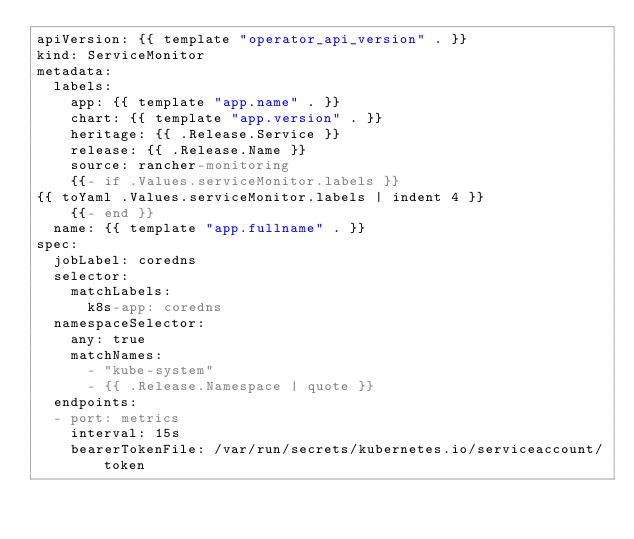<code> <loc_0><loc_0><loc_500><loc_500><_YAML_>apiVersion: {{ template "operator_api_version" . }}
kind: ServiceMonitor
metadata:
  labels:
    app: {{ template "app.name" . }}
    chart: {{ template "app.version" . }}
    heritage: {{ .Release.Service }}
    release: {{ .Release.Name }}
    source: rancher-monitoring
    {{- if .Values.serviceMonitor.labels }}
{{ toYaml .Values.serviceMonitor.labels | indent 4 }}
    {{- end }}  
  name: {{ template "app.fullname" . }}
spec:
  jobLabel: coredns
  selector:
    matchLabels:
      k8s-app: coredns
  namespaceSelector:
    any: true
    matchNames:
      - "kube-system"
      - {{ .Release.Namespace | quote }}
  endpoints:
  - port: metrics
    interval: 15s
    bearerTokenFile: /var/run/secrets/kubernetes.io/serviceaccount/token
</code> 